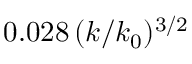<formula> <loc_0><loc_0><loc_500><loc_500>0 . 0 2 8 \, ( k / k _ { 0 } ) ^ { 3 / 2 }</formula> 